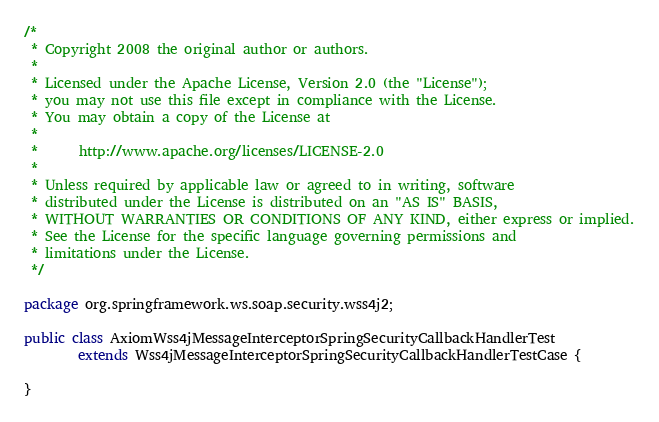<code> <loc_0><loc_0><loc_500><loc_500><_Java_>/*
 * Copyright 2008 the original author or authors.
 *
 * Licensed under the Apache License, Version 2.0 (the "License");
 * you may not use this file except in compliance with the License.
 * You may obtain a copy of the License at
 *
 *      http://www.apache.org/licenses/LICENSE-2.0
 *
 * Unless required by applicable law or agreed to in writing, software
 * distributed under the License is distributed on an "AS IS" BASIS,
 * WITHOUT WARRANTIES OR CONDITIONS OF ANY KIND, either express or implied.
 * See the License for the specific language governing permissions and
 * limitations under the License.
 */

package org.springframework.ws.soap.security.wss4j2;

public class AxiomWss4jMessageInterceptorSpringSecurityCallbackHandlerTest
		extends Wss4jMessageInterceptorSpringSecurityCallbackHandlerTestCase {

}</code> 